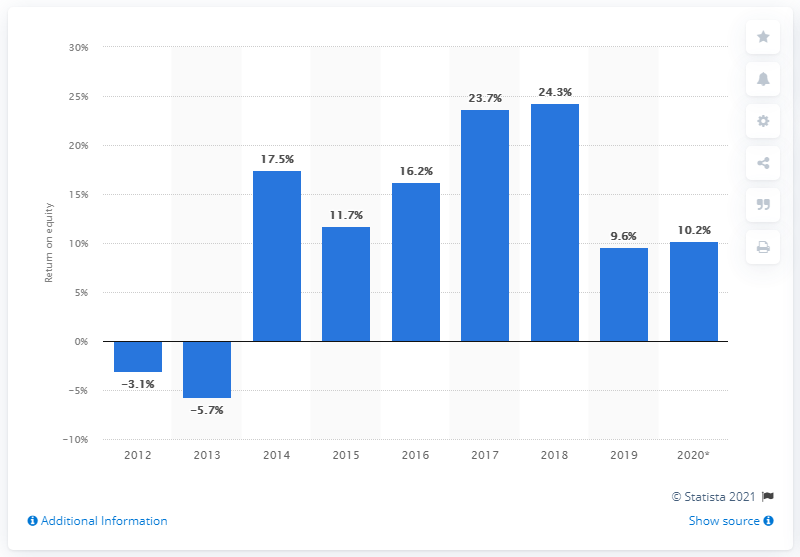Outline some significant characteristics in this image. The total value of the NatWest group in 2020 was 9.6... 